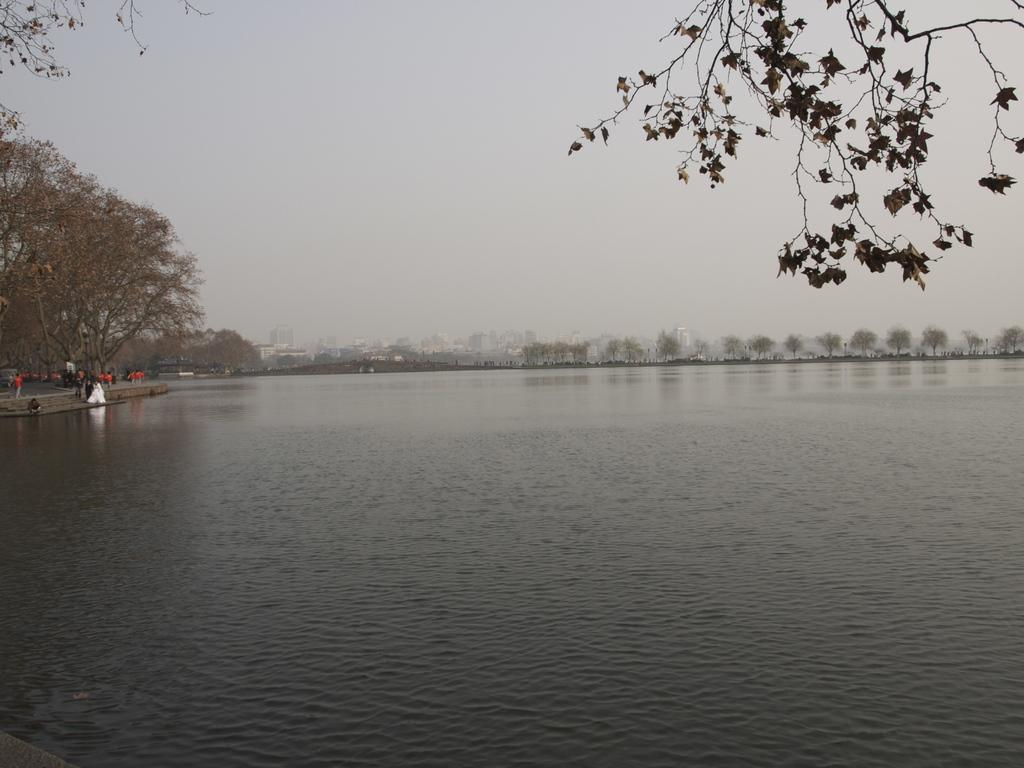What type of natural feature is visible in the image? There is a sea in the image. What are the people on the left side of the image doing? The people are walking on the road on the left side of the image. What can be seen in the background of the image? There are many trees and buildings in the background of the image. What is visible at the top of the image? The sky is visible at the top of the image. How many dimes can be seen on the page in the image? There is no page or dimes present in the image. What is the hope of the people walking on the road in the image? There is no indication of the people's hopes or intentions in the image. 